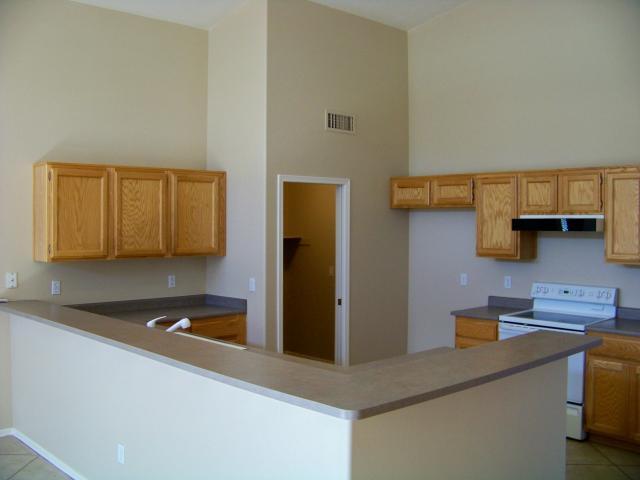Are there ample electrical outlets?
Write a very short answer. Yes. Is anyone living in this home?
Give a very brief answer. No. What room is this?
Keep it brief. Kitchen. 